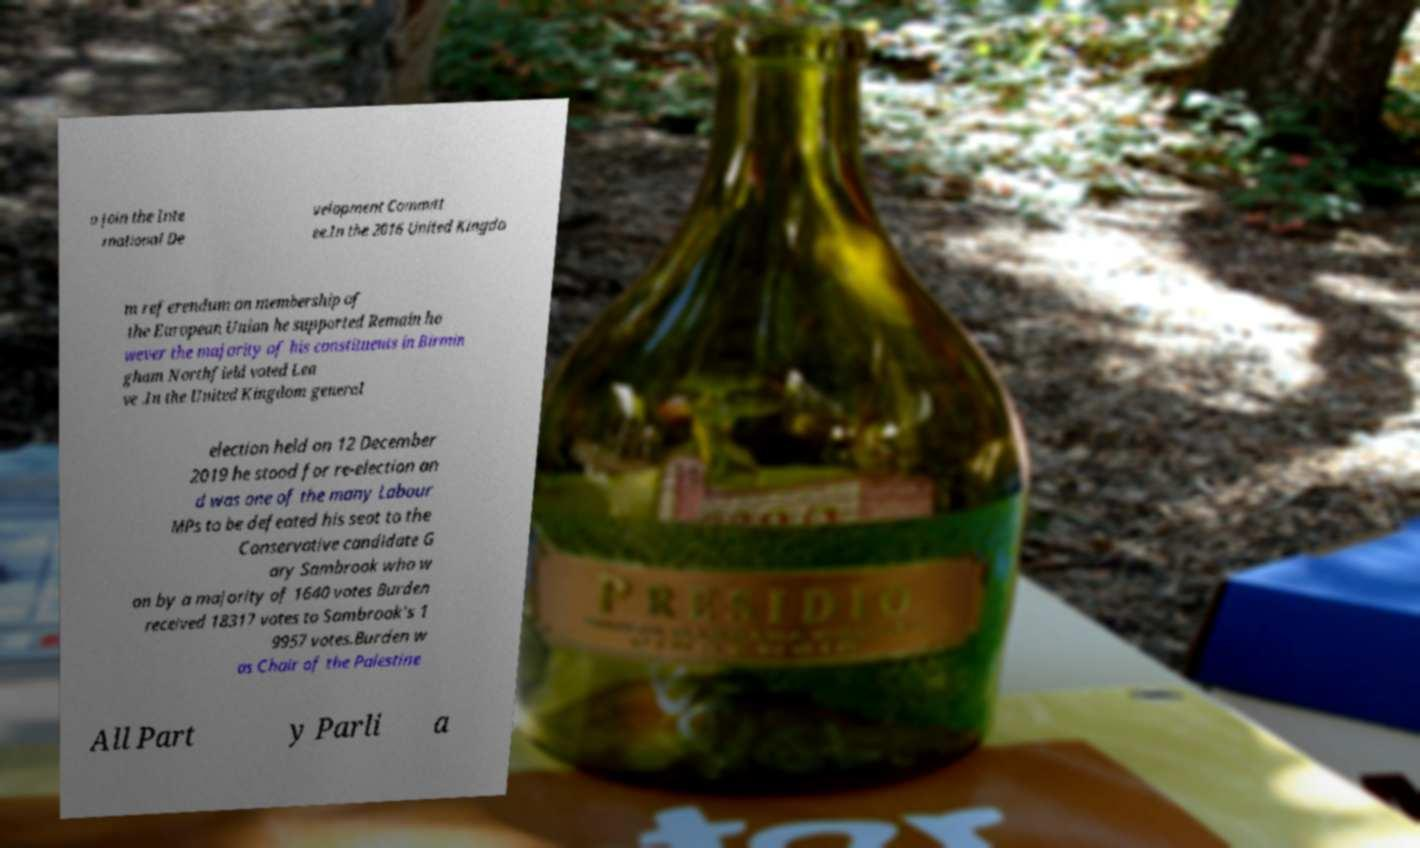There's text embedded in this image that I need extracted. Can you transcribe it verbatim? o join the Inte rnational De velopment Committ ee.In the 2016 United Kingdo m referendum on membership of the European Union he supported Remain ho wever the majority of his constituents in Birmin gham Northfield voted Lea ve .In the United Kingdom general election held on 12 December 2019 he stood for re-election an d was one of the many Labour MPs to be defeated his seat to the Conservative candidate G ary Sambrook who w on by a majority of 1640 votes Burden received 18317 votes to Sambrook's 1 9957 votes.Burden w as Chair of the Palestine All Part y Parli a 